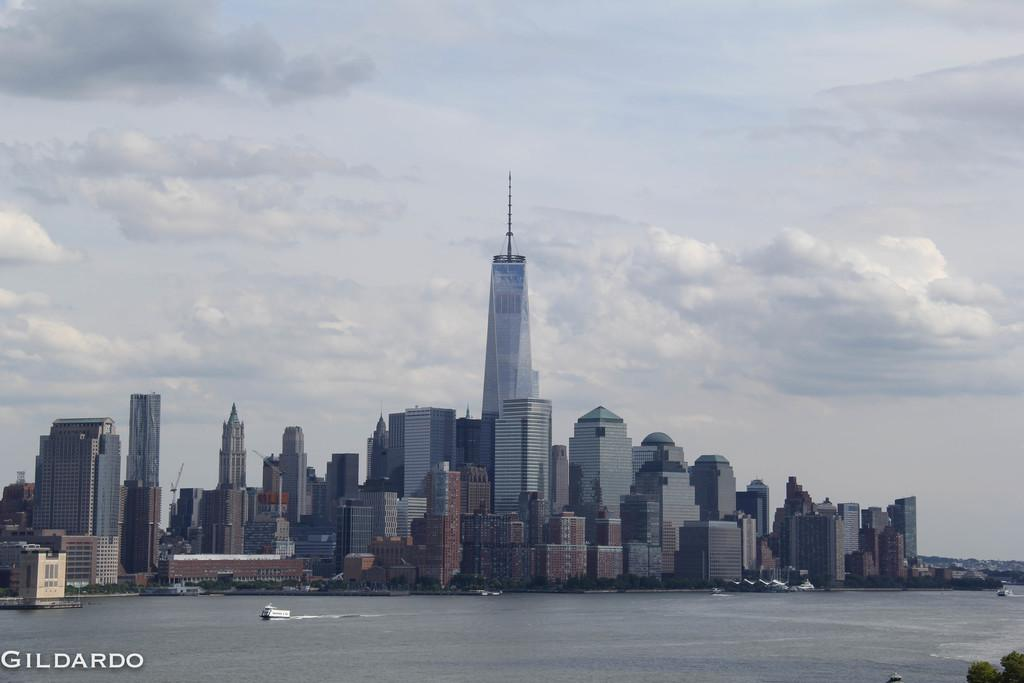What type of structures can be seen in the image? There are buildings in the image. What architectural feature can be seen on the buildings? Windows are visible in the image. What type of vegetation is present in the image? There are trees in the image. What is visible in the background of the image? The sky is visible in the image. What type of vehicles can be seen on the water surface in the image? There are ships on the water surface in the image. How many toes can be seen on the family members in the image? There is no family present in the image, and therefore no toes can be observed. What type of wind can be seen blowing in the image? There is no wind present in the image; it is a still image. 